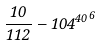Convert formula to latex. <formula><loc_0><loc_0><loc_500><loc_500>\frac { 1 0 } { 1 1 2 } - { 1 0 4 ^ { 4 0 } } ^ { 6 }</formula> 